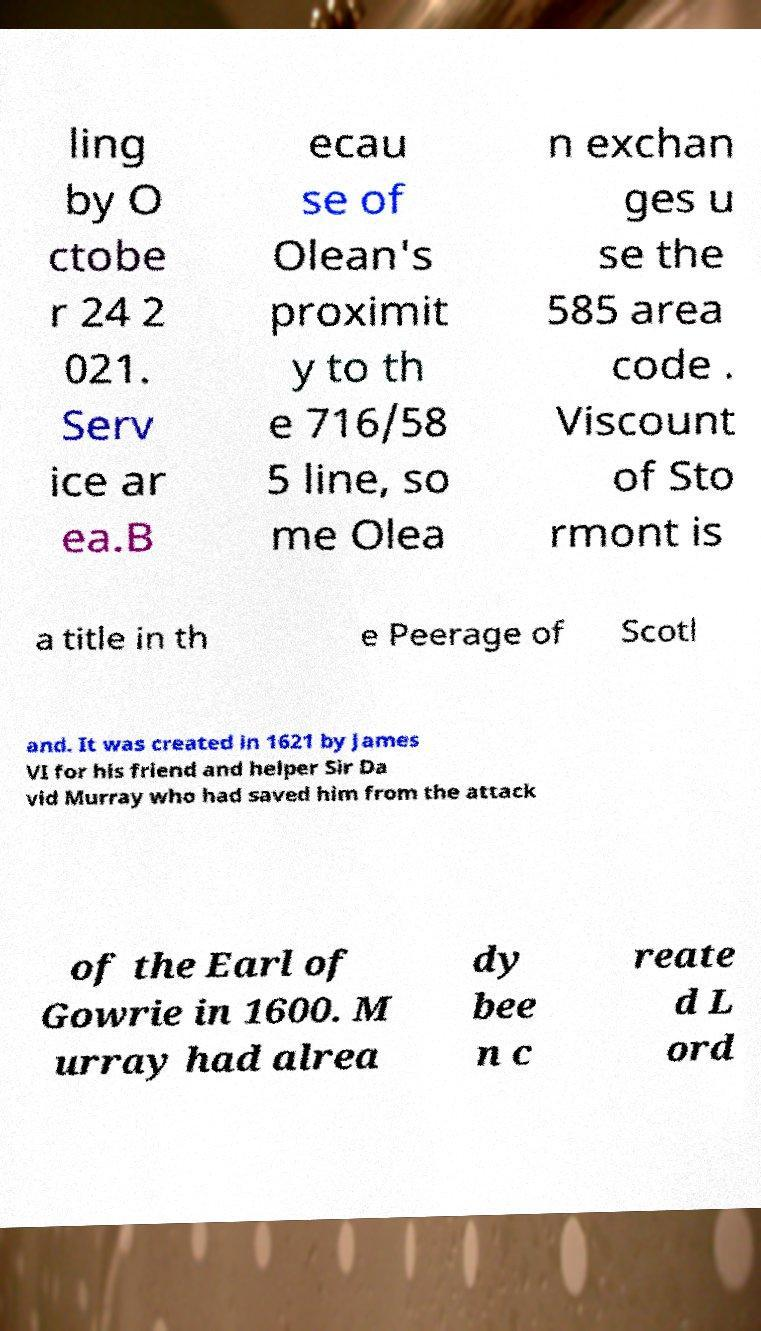Could you extract and type out the text from this image? ling by O ctobe r 24 2 021. Serv ice ar ea.B ecau se of Olean's proximit y to th e 716/58 5 line, so me Olea n exchan ges u se the 585 area code . Viscount of Sto rmont is a title in th e Peerage of Scotl and. It was created in 1621 by James VI for his friend and helper Sir Da vid Murray who had saved him from the attack of the Earl of Gowrie in 1600. M urray had alrea dy bee n c reate d L ord 